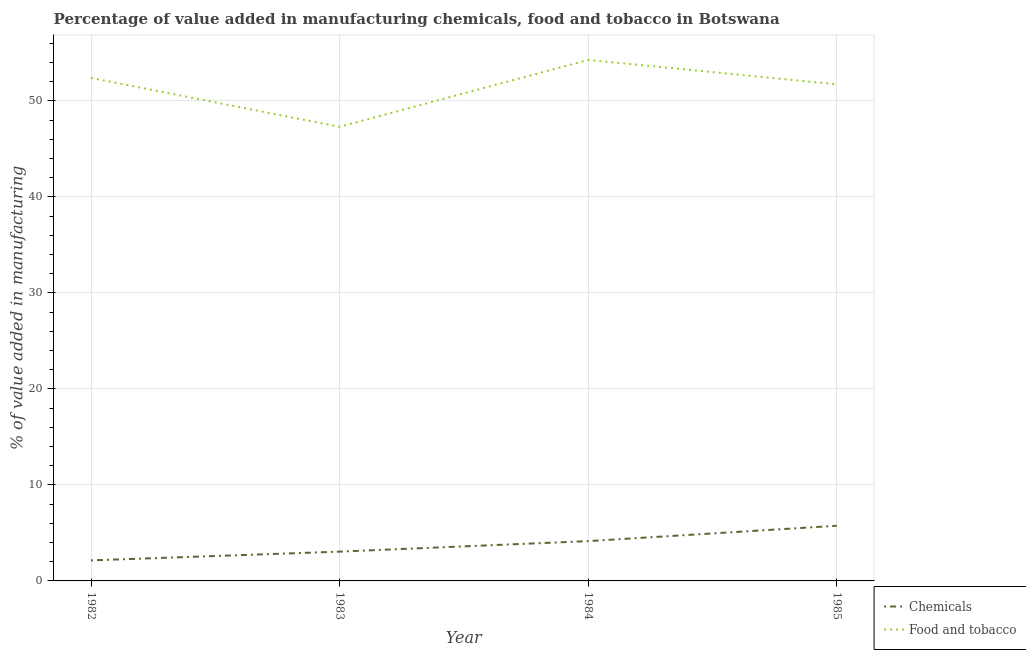What is the value added by manufacturing food and tobacco in 1985?
Offer a very short reply. 51.72. Across all years, what is the maximum value added by  manufacturing chemicals?
Make the answer very short. 5.75. Across all years, what is the minimum value added by manufacturing food and tobacco?
Your response must be concise. 47.3. In which year was the value added by manufacturing food and tobacco minimum?
Give a very brief answer. 1983. What is the total value added by manufacturing food and tobacco in the graph?
Make the answer very short. 205.69. What is the difference between the value added by  manufacturing chemicals in 1984 and that in 1985?
Your response must be concise. -1.6. What is the difference between the value added by  manufacturing chemicals in 1983 and the value added by manufacturing food and tobacco in 1984?
Your answer should be compact. -51.22. What is the average value added by manufacturing food and tobacco per year?
Ensure brevity in your answer.  51.42. In the year 1982, what is the difference between the value added by manufacturing food and tobacco and value added by  manufacturing chemicals?
Provide a short and direct response. 50.25. What is the ratio of the value added by manufacturing food and tobacco in 1983 to that in 1985?
Ensure brevity in your answer.  0.91. Is the value added by  manufacturing chemicals in 1982 less than that in 1983?
Make the answer very short. Yes. What is the difference between the highest and the second highest value added by  manufacturing chemicals?
Your answer should be very brief. 1.6. What is the difference between the highest and the lowest value added by  manufacturing chemicals?
Offer a terse response. 3.61. Is the sum of the value added by  manufacturing chemicals in 1982 and 1985 greater than the maximum value added by manufacturing food and tobacco across all years?
Your answer should be very brief. No. Does the value added by  manufacturing chemicals monotonically increase over the years?
Your answer should be very brief. Yes. Is the value added by  manufacturing chemicals strictly greater than the value added by manufacturing food and tobacco over the years?
Keep it short and to the point. No. Is the value added by manufacturing food and tobacco strictly less than the value added by  manufacturing chemicals over the years?
Provide a succinct answer. No. How many lines are there?
Your response must be concise. 2. How many years are there in the graph?
Your answer should be very brief. 4. Does the graph contain any zero values?
Your answer should be compact. No. What is the title of the graph?
Your answer should be compact. Percentage of value added in manufacturing chemicals, food and tobacco in Botswana. Does "Resident workers" appear as one of the legend labels in the graph?
Give a very brief answer. No. What is the label or title of the Y-axis?
Make the answer very short. % of value added in manufacturing. What is the % of value added in manufacturing in Chemicals in 1982?
Ensure brevity in your answer.  2.14. What is the % of value added in manufacturing of Food and tobacco in 1982?
Ensure brevity in your answer.  52.39. What is the % of value added in manufacturing of Chemicals in 1983?
Your answer should be compact. 3.05. What is the % of value added in manufacturing of Food and tobacco in 1983?
Keep it short and to the point. 47.3. What is the % of value added in manufacturing in Chemicals in 1984?
Provide a short and direct response. 4.15. What is the % of value added in manufacturing of Food and tobacco in 1984?
Offer a very short reply. 54.27. What is the % of value added in manufacturing of Chemicals in 1985?
Your response must be concise. 5.75. What is the % of value added in manufacturing in Food and tobacco in 1985?
Your answer should be compact. 51.72. Across all years, what is the maximum % of value added in manufacturing in Chemicals?
Provide a short and direct response. 5.75. Across all years, what is the maximum % of value added in manufacturing in Food and tobacco?
Offer a very short reply. 54.27. Across all years, what is the minimum % of value added in manufacturing in Chemicals?
Make the answer very short. 2.14. Across all years, what is the minimum % of value added in manufacturing of Food and tobacco?
Ensure brevity in your answer.  47.3. What is the total % of value added in manufacturing of Chemicals in the graph?
Offer a terse response. 15.08. What is the total % of value added in manufacturing of Food and tobacco in the graph?
Offer a terse response. 205.69. What is the difference between the % of value added in manufacturing in Chemicals in 1982 and that in 1983?
Offer a terse response. -0.91. What is the difference between the % of value added in manufacturing of Food and tobacco in 1982 and that in 1983?
Provide a succinct answer. 5.09. What is the difference between the % of value added in manufacturing in Chemicals in 1982 and that in 1984?
Provide a succinct answer. -2.01. What is the difference between the % of value added in manufacturing in Food and tobacco in 1982 and that in 1984?
Your response must be concise. -1.88. What is the difference between the % of value added in manufacturing in Chemicals in 1982 and that in 1985?
Your answer should be very brief. -3.61. What is the difference between the % of value added in manufacturing of Food and tobacco in 1982 and that in 1985?
Your answer should be very brief. 0.67. What is the difference between the % of value added in manufacturing of Chemicals in 1983 and that in 1984?
Your answer should be compact. -1.09. What is the difference between the % of value added in manufacturing of Food and tobacco in 1983 and that in 1984?
Provide a short and direct response. -6.97. What is the difference between the % of value added in manufacturing in Chemicals in 1983 and that in 1985?
Your response must be concise. -2.7. What is the difference between the % of value added in manufacturing in Food and tobacco in 1983 and that in 1985?
Offer a terse response. -4.42. What is the difference between the % of value added in manufacturing in Chemicals in 1984 and that in 1985?
Keep it short and to the point. -1.6. What is the difference between the % of value added in manufacturing of Food and tobacco in 1984 and that in 1985?
Give a very brief answer. 2.54. What is the difference between the % of value added in manufacturing of Chemicals in 1982 and the % of value added in manufacturing of Food and tobacco in 1983?
Ensure brevity in your answer.  -45.16. What is the difference between the % of value added in manufacturing of Chemicals in 1982 and the % of value added in manufacturing of Food and tobacco in 1984?
Keep it short and to the point. -52.13. What is the difference between the % of value added in manufacturing of Chemicals in 1982 and the % of value added in manufacturing of Food and tobacco in 1985?
Your answer should be very brief. -49.59. What is the difference between the % of value added in manufacturing of Chemicals in 1983 and the % of value added in manufacturing of Food and tobacco in 1984?
Your answer should be compact. -51.22. What is the difference between the % of value added in manufacturing in Chemicals in 1983 and the % of value added in manufacturing in Food and tobacco in 1985?
Offer a terse response. -48.67. What is the difference between the % of value added in manufacturing of Chemicals in 1984 and the % of value added in manufacturing of Food and tobacco in 1985?
Offer a terse response. -47.58. What is the average % of value added in manufacturing in Chemicals per year?
Offer a terse response. 3.77. What is the average % of value added in manufacturing of Food and tobacco per year?
Give a very brief answer. 51.42. In the year 1982, what is the difference between the % of value added in manufacturing of Chemicals and % of value added in manufacturing of Food and tobacco?
Your answer should be compact. -50.25. In the year 1983, what is the difference between the % of value added in manufacturing of Chemicals and % of value added in manufacturing of Food and tobacco?
Keep it short and to the point. -44.25. In the year 1984, what is the difference between the % of value added in manufacturing in Chemicals and % of value added in manufacturing in Food and tobacco?
Give a very brief answer. -50.12. In the year 1985, what is the difference between the % of value added in manufacturing of Chemicals and % of value added in manufacturing of Food and tobacco?
Make the answer very short. -45.98. What is the ratio of the % of value added in manufacturing of Chemicals in 1982 to that in 1983?
Offer a terse response. 0.7. What is the ratio of the % of value added in manufacturing of Food and tobacco in 1982 to that in 1983?
Make the answer very short. 1.11. What is the ratio of the % of value added in manufacturing of Chemicals in 1982 to that in 1984?
Keep it short and to the point. 0.52. What is the ratio of the % of value added in manufacturing of Food and tobacco in 1982 to that in 1984?
Offer a very short reply. 0.97. What is the ratio of the % of value added in manufacturing of Chemicals in 1982 to that in 1985?
Give a very brief answer. 0.37. What is the ratio of the % of value added in manufacturing of Food and tobacco in 1982 to that in 1985?
Give a very brief answer. 1.01. What is the ratio of the % of value added in manufacturing in Chemicals in 1983 to that in 1984?
Your response must be concise. 0.74. What is the ratio of the % of value added in manufacturing in Food and tobacco in 1983 to that in 1984?
Provide a succinct answer. 0.87. What is the ratio of the % of value added in manufacturing in Chemicals in 1983 to that in 1985?
Offer a very short reply. 0.53. What is the ratio of the % of value added in manufacturing of Food and tobacco in 1983 to that in 1985?
Provide a succinct answer. 0.91. What is the ratio of the % of value added in manufacturing of Chemicals in 1984 to that in 1985?
Your answer should be compact. 0.72. What is the ratio of the % of value added in manufacturing of Food and tobacco in 1984 to that in 1985?
Your response must be concise. 1.05. What is the difference between the highest and the second highest % of value added in manufacturing in Chemicals?
Offer a terse response. 1.6. What is the difference between the highest and the second highest % of value added in manufacturing of Food and tobacco?
Make the answer very short. 1.88. What is the difference between the highest and the lowest % of value added in manufacturing in Chemicals?
Give a very brief answer. 3.61. What is the difference between the highest and the lowest % of value added in manufacturing of Food and tobacco?
Provide a short and direct response. 6.97. 